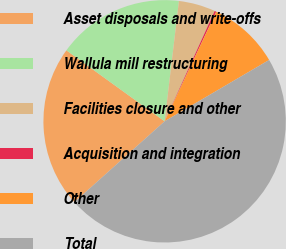Convert chart to OTSL. <chart><loc_0><loc_0><loc_500><loc_500><pie_chart><fcel>Asset disposals and write-offs<fcel>Wallula mill restructuring<fcel>Facilities closure and other<fcel>Acquisition and integration<fcel>Other<fcel>Total<nl><fcel>21.59%<fcel>16.93%<fcel>4.89%<fcel>0.23%<fcel>9.55%<fcel>46.82%<nl></chart> 